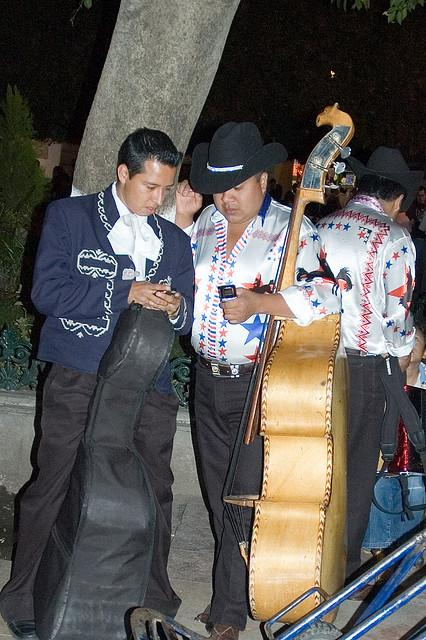What kind of music band do they play music in?

Choices:
A) pop
B) rock
C) mariachi
D) country mariachi 